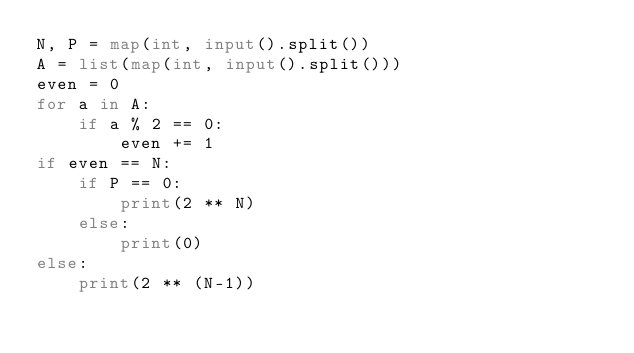<code> <loc_0><loc_0><loc_500><loc_500><_Python_>N, P = map(int, input().split())
A = list(map(int, input().split()))
even = 0
for a in A:
	if a % 2 == 0:
		even += 1
if even == N:
	if P == 0:
		print(2 ** N)
	else:
		print(0)
else:
	print(2 ** (N-1))</code> 